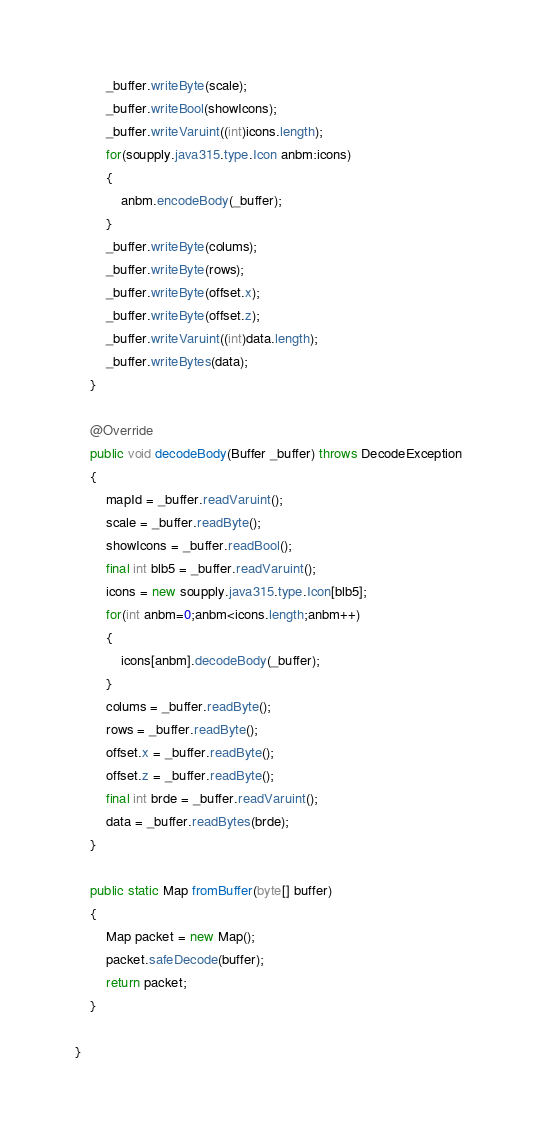<code> <loc_0><loc_0><loc_500><loc_500><_Java_>        _buffer.writeByte(scale);
        _buffer.writeBool(showIcons);
        _buffer.writeVaruint((int)icons.length);
        for(soupply.java315.type.Icon anbm:icons)
        {
            anbm.encodeBody(_buffer);
        }
        _buffer.writeByte(colums);
        _buffer.writeByte(rows);
        _buffer.writeByte(offset.x);
        _buffer.writeByte(offset.z);
        _buffer.writeVaruint((int)data.length);
        _buffer.writeBytes(data);
    }

    @Override
    public void decodeBody(Buffer _buffer) throws DecodeException
    {
        mapId = _buffer.readVaruint();
        scale = _buffer.readByte();
        showIcons = _buffer.readBool();
        final int blb5 = _buffer.readVaruint();
        icons = new soupply.java315.type.Icon[blb5];
        for(int anbm=0;anbm<icons.length;anbm++)
        {
            icons[anbm].decodeBody(_buffer);
        }
        colums = _buffer.readByte();
        rows = _buffer.readByte();
        offset.x = _buffer.readByte();
        offset.z = _buffer.readByte();
        final int brde = _buffer.readVaruint();
        data = _buffer.readBytes(brde);
    }

    public static Map fromBuffer(byte[] buffer)
    {
        Map packet = new Map();
        packet.safeDecode(buffer);
        return packet;
    }

}
</code> 